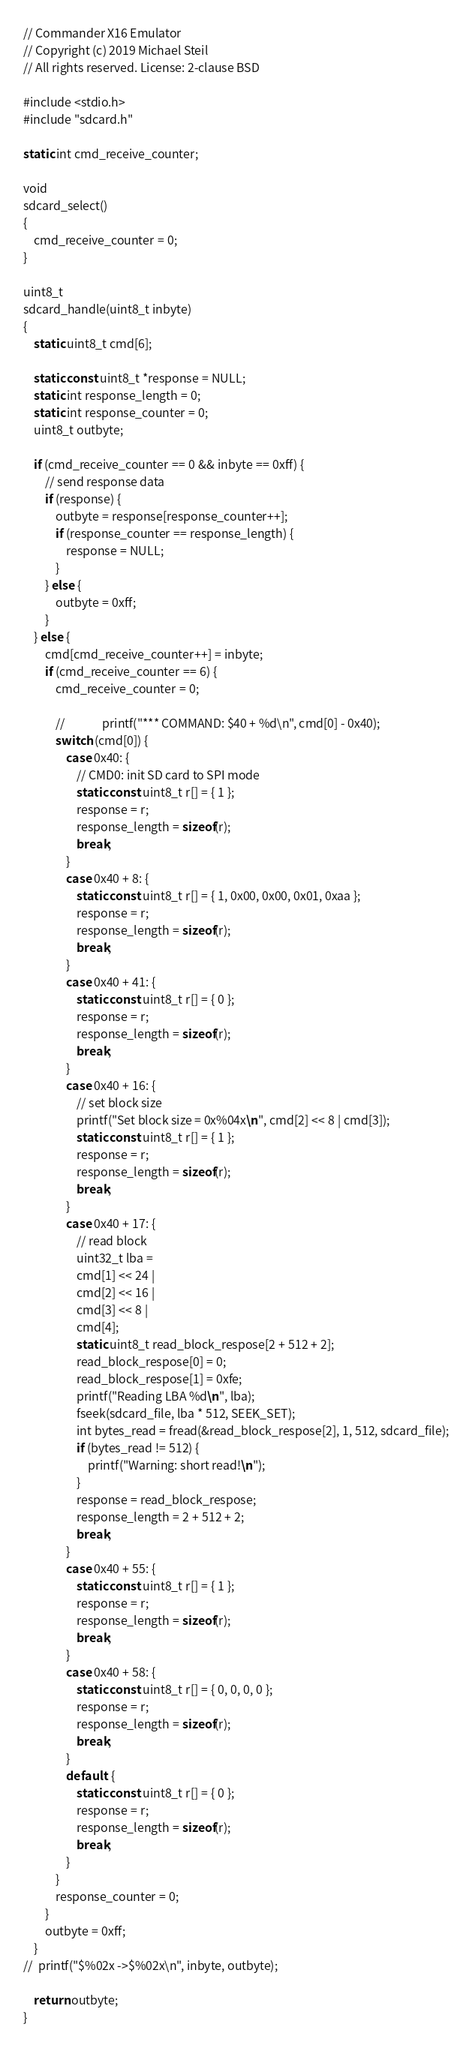<code> <loc_0><loc_0><loc_500><loc_500><_C_>// Commander X16 Emulator
// Copyright (c) 2019 Michael Steil
// All rights reserved. License: 2-clause BSD

#include <stdio.h>
#include "sdcard.h"

static int cmd_receive_counter;

void
sdcard_select()
{
	cmd_receive_counter = 0;
}

uint8_t
sdcard_handle(uint8_t inbyte)
{
	static uint8_t cmd[6];

	static const uint8_t *response = NULL;
	static int response_length = 0;
	static int response_counter = 0;
	uint8_t outbyte;

	if (cmd_receive_counter == 0 && inbyte == 0xff) {
		// send response data
		if (response) {
			outbyte = response[response_counter++];
			if (response_counter == response_length) {
				response = NULL;
			}
		} else {
			outbyte = 0xff;
		}
	} else {
		cmd[cmd_receive_counter++] = inbyte;
		if (cmd_receive_counter == 6) {
			cmd_receive_counter = 0;

			//				printf("*** COMMAND: $40 + %d\n", cmd[0] - 0x40);
			switch (cmd[0]) {
				case 0x40: {
					// CMD0: init SD card to SPI mode
					static const uint8_t r[] = { 1 };
					response = r;
					response_length = sizeof(r);
					break;
				}
				case 0x40 + 8: {
					static const uint8_t r[] = { 1, 0x00, 0x00, 0x01, 0xaa };
					response = r;
					response_length = sizeof(r);
					break;
				}
				case 0x40 + 41: {
					static const uint8_t r[] = { 0 };
					response = r;
					response_length = sizeof(r);
					break;
				}
				case 0x40 + 16: {
					// set block size
					printf("Set block size = 0x%04x\n", cmd[2] << 8 | cmd[3]);
					static const uint8_t r[] = { 1 };
					response = r;
					response_length = sizeof(r);
					break;
				}
				case 0x40 + 17: {
					// read block
					uint32_t lba =
					cmd[1] << 24 |
					cmd[2] << 16 |
					cmd[3] << 8 |
					cmd[4];
					static uint8_t read_block_respose[2 + 512 + 2];
					read_block_respose[0] = 0;
					read_block_respose[1] = 0xfe;
					printf("Reading LBA %d\n", lba);
					fseek(sdcard_file, lba * 512, SEEK_SET);
					int bytes_read = fread(&read_block_respose[2], 1, 512, sdcard_file);
					if (bytes_read != 512) {
						printf("Warning: short read!\n");
					}
					response = read_block_respose;
					response_length = 2 + 512 + 2;
					break;
				}
				case 0x40 + 55: {
					static const uint8_t r[] = { 1 };
					response = r;
					response_length = sizeof(r);
					break;
				}
				case 0x40 + 58: {
					static const uint8_t r[] = { 0, 0, 0, 0 };
					response = r;
					response_length = sizeof(r);
					break;
				}
				default: {
					static const uint8_t r[] = { 0 };
					response = r;
					response_length = sizeof(r);
					break;
				}
			}
			response_counter = 0;
		}
		outbyte = 0xff;
	}
//	printf("$%02x ->$%02x\n", inbyte, outbyte);

	return outbyte;
}

</code> 